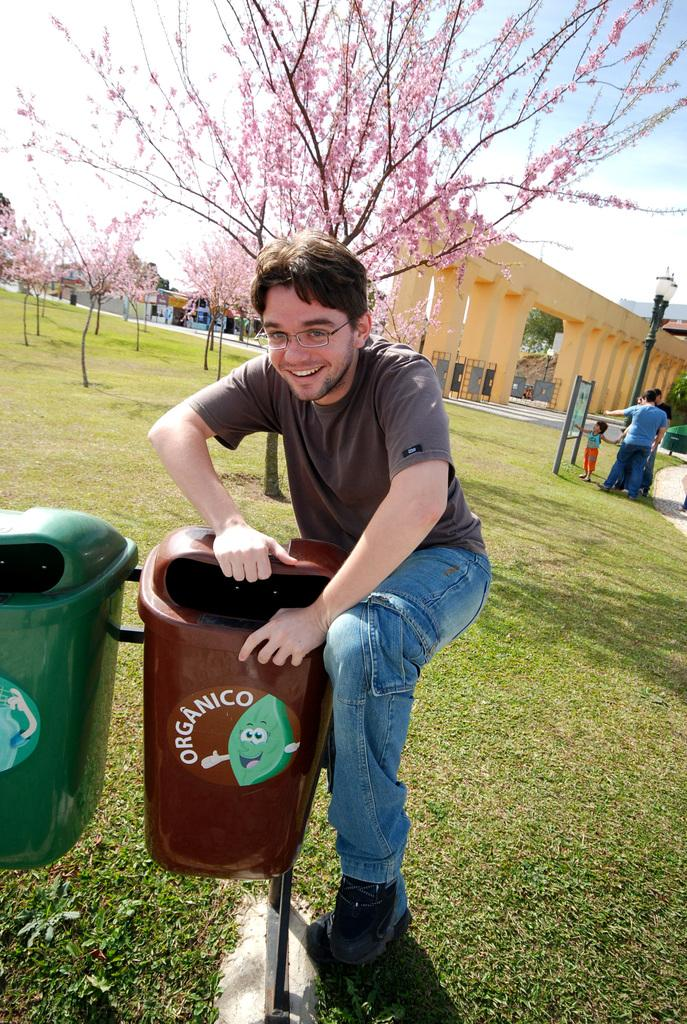<image>
Provide a brief description of the given image. College male student holding a Organico trash bin 